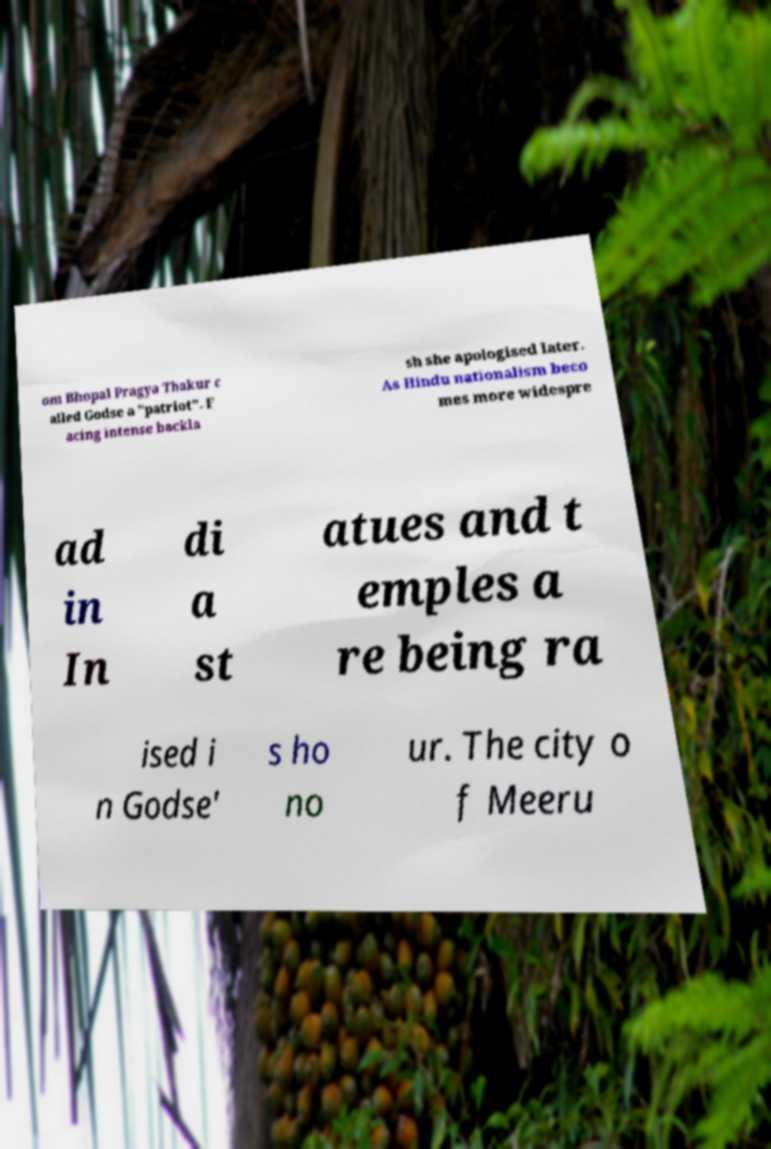Please read and relay the text visible in this image. What does it say? om Bhopal Pragya Thakur c alled Godse a "patriot". F acing intense backla sh she apologised later. As Hindu nationalism beco mes more widespre ad in In di a st atues and t emples a re being ra ised i n Godse' s ho no ur. The city o f Meeru 